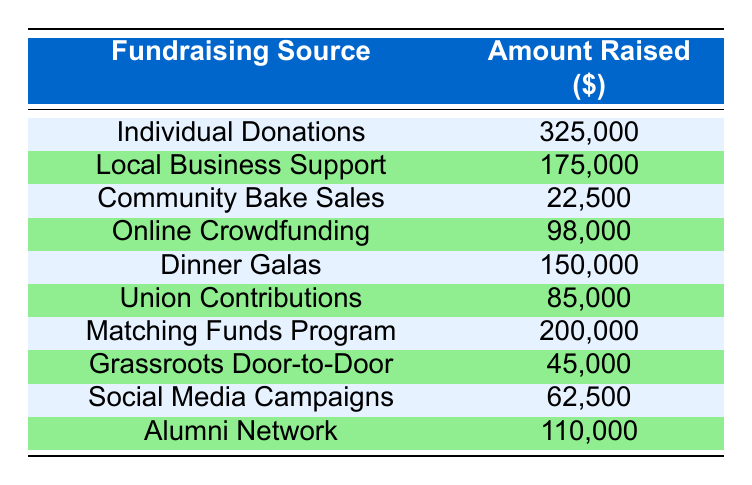What is the total amount raised from individual donations? The table shows that the amount raised from individual donations is explicitly listed as 325000.
Answer: 325000 Which fundraising source generated the least amount of money? By examining the amounts raised by each source, Community Bake Sales has the lowest value at 22500.
Answer: Community Bake Sales What is the total amount raised from local business support and alumni network? Adding the values for both sources: Local Business Support is 175000 and Alumni Network is 110000. Therefore, the total is 175000 + 110000 = 285000.
Answer: 285000 Is the amount raised from online crowdfunding greater than the amount raised from dinner galas? The table indicates that online crowdfunding raised 98000 while dinner galas raised 150000. Since 98000 is less than 150000, the statement is false.
Answer: No What is the difference in fundraising amounts between matching funds program and grassroots door-to-door? The matching funds program total is 200000, and grassroots door-to-door is 45000. Calculating the difference: 200000 - 45000 = 155000.
Answer: 155000 Which fundraising sources raised a total of more than 200000? From the table, only the individual donations (325000) and matching funds program (200000) exceed the amount of 200000.
Answer: Individual donations, Matching funds program What is the average amount raised from all the fundraising sources? To find the average, add all the amounts raised: 325000 + 175000 + 22500 + 98000 + 150000 + 85000 + 200000 + 45000 + 62500 + 110000 = 1100000. There are 10 sources, so divide by 10: 1100000 / 10 = 110000.
Answer: 110000 Is the total amount from union contributions more than the total from community bake sales? Since the table shows union contributions at 85000 and community bake sales at 22500, and 85000 is greater than 22500, this statement is true.
Answer: Yes Which two sources combined raised the most funds, and what is that total? Looking at the table, Individual Donations (325000) and Matching Funds Program (200000) have the highest values. Their combined total is 325000 + 200000 = 525000.
Answer: 525000 